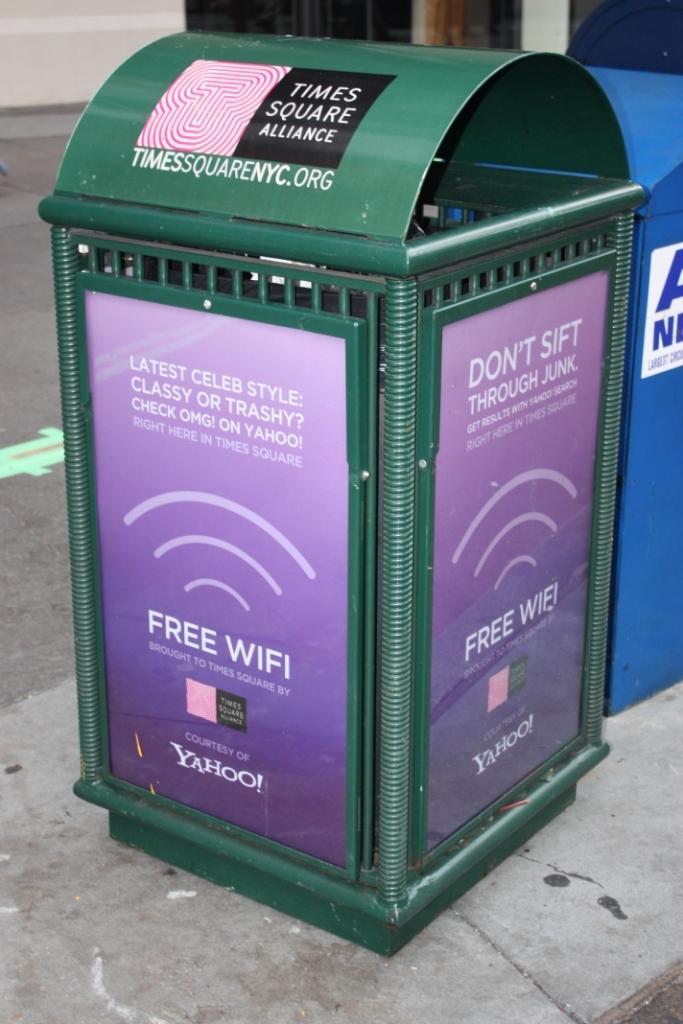<image>
Relay a brief, clear account of the picture shown. A green trash container has a purple sign with Yahoo on it. 